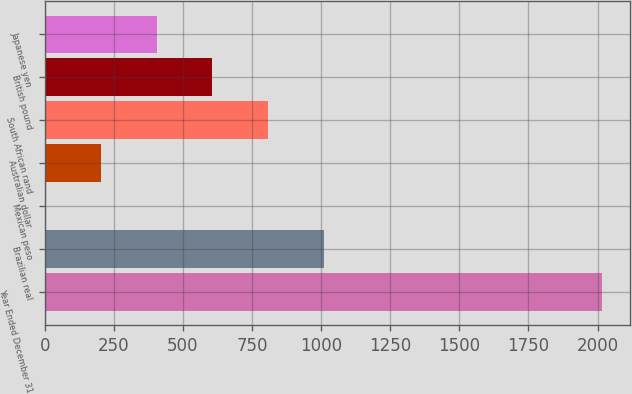Convert chart. <chart><loc_0><loc_0><loc_500><loc_500><bar_chart><fcel>Year Ended December 31<fcel>Brazilian real<fcel>Mexican peso<fcel>Australian dollar<fcel>South African rand<fcel>British pound<fcel>Japanese yen<nl><fcel>2017<fcel>1009.5<fcel>2<fcel>203.5<fcel>808<fcel>606.5<fcel>405<nl></chart> 